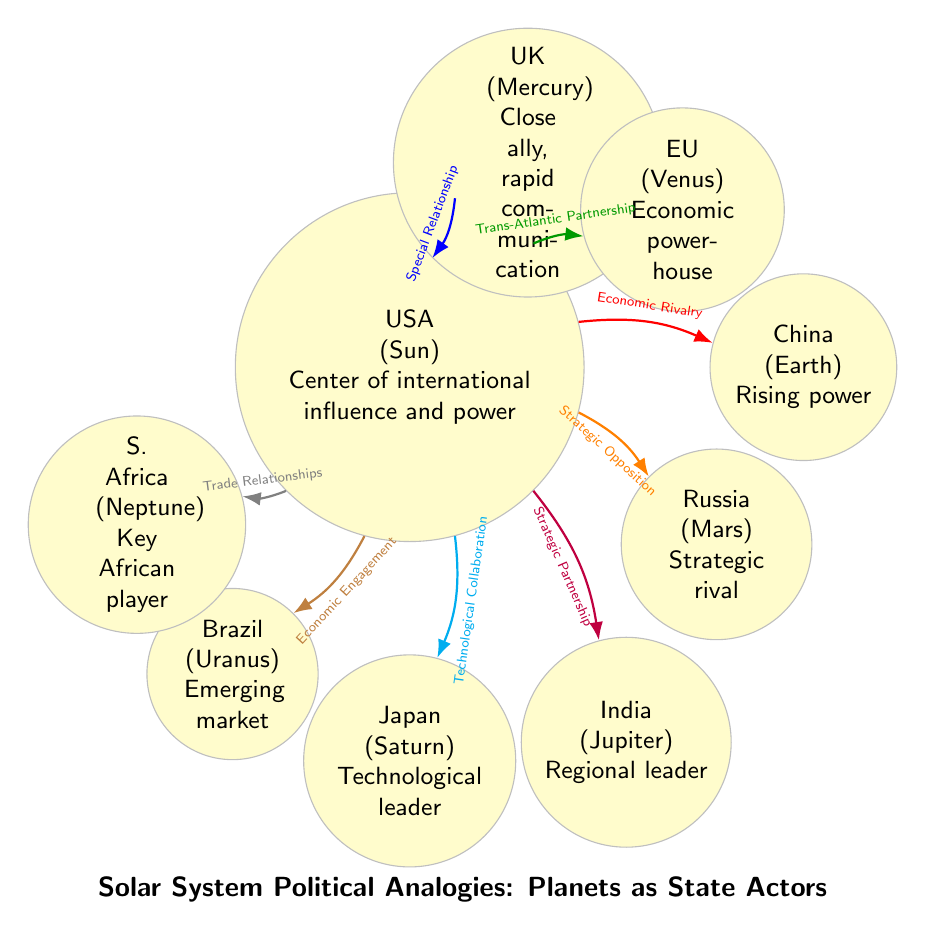What planet represents China? The diagram assigns the label "China" to the planet "Earth." This is indicated directly in the node labeled "Earth."
Answer: Earth How many planets are represented in the diagram? By counting the individual nodes designated as planets in the diagram, we see there are a total of eight planets represented.
Answer: 8 What type of relationship exists between the USA and Russia? The connection line marked as "Strategic Opposition" links the nodes "USA" (Sun) and "Russia" (Mars), indicating this particular relationship type.
Answer: Strategic Opposition Which planet is characterized as "Economic powerhouse"? The node labeled "EU" (Venus) clearly indicates this characteristic description within its text.
Answer: EU What type of collaboration is indicated between the USA and Japan? The line connecting the "USA" (Sun) and "Japan" (Saturn) is labeled "Technological Collaboration," directly reflecting the nature of their relationship.
Answer: Technological Collaboration How is Brazil classified in this analogy? In the diagram, Brazil is represented by the planet "Uranus," with the description "Emerging market" directly stated in its node.
Answer: Emerging market What is the relationship labeled between the USA and the UK? The relationship labeled "Special Relationship" directly connects the "USA" (Sun) to "UK" (Mercury), defining their interaction.
Answer: Special Relationship Which planet is at the center of the diagram? The node at the center is labeled "USA" (Sun), making it the focal point of the entire diagram.
Answer: USA What role does India play in this solar system analogy? India is represented by "Jupiter," characterized as a "Regional leader," as stated in its corresponding node.
Answer: Regional leader 